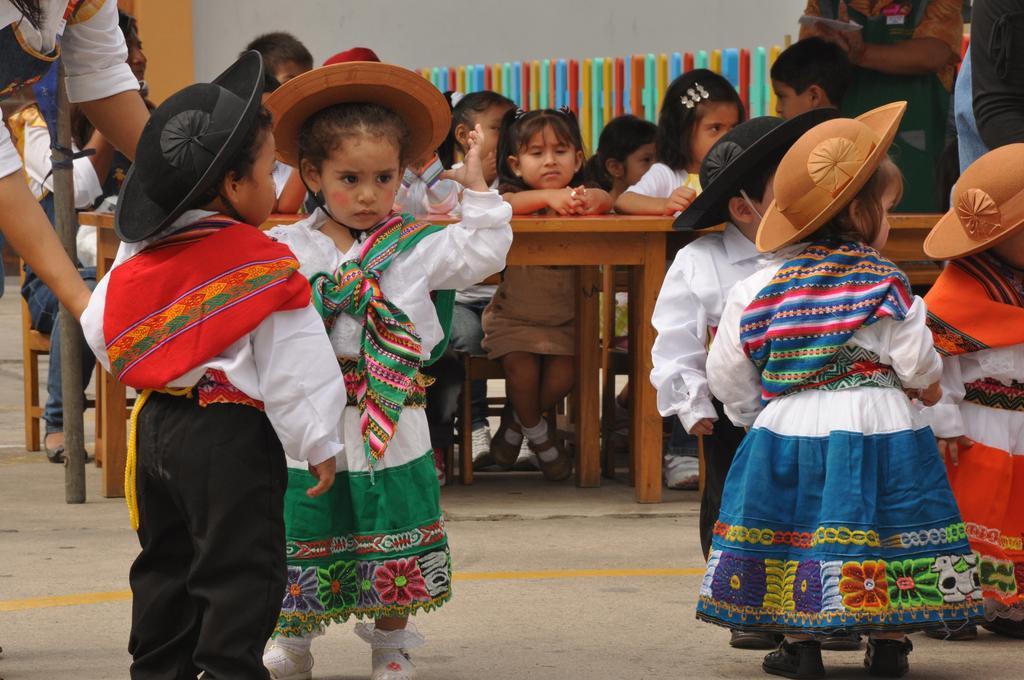Describe this image in one or two sentences. In the center of the image there is a girl wearing a white color dress and a brown color hat. Besides her there is a boy who is wearing white color shirt and red color scarf. he is also wearing a black color hat. At the right side of the image there are three children. At the background of the image there are children sitting on bench. At the bottom of the image there is a road. 